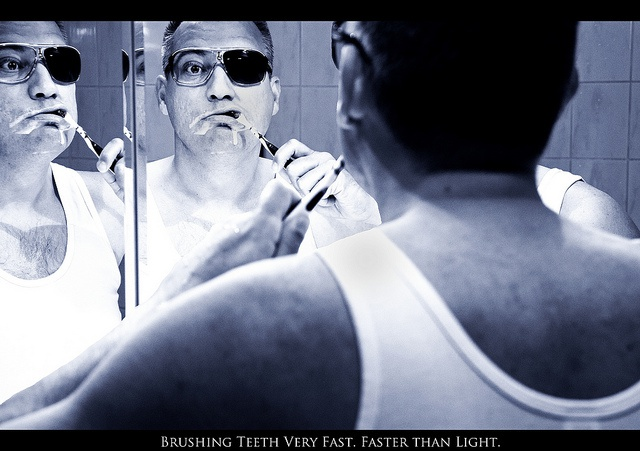Describe the objects in this image and their specific colors. I can see people in black, lavender, and darkgray tones, people in black, white, and darkgray tones, people in black, lightgray, and darkgray tones, people in black, white, gray, and darkgray tones, and toothbrush in black, white, and darkgray tones in this image. 